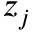<formula> <loc_0><loc_0><loc_500><loc_500>z _ { j }</formula> 